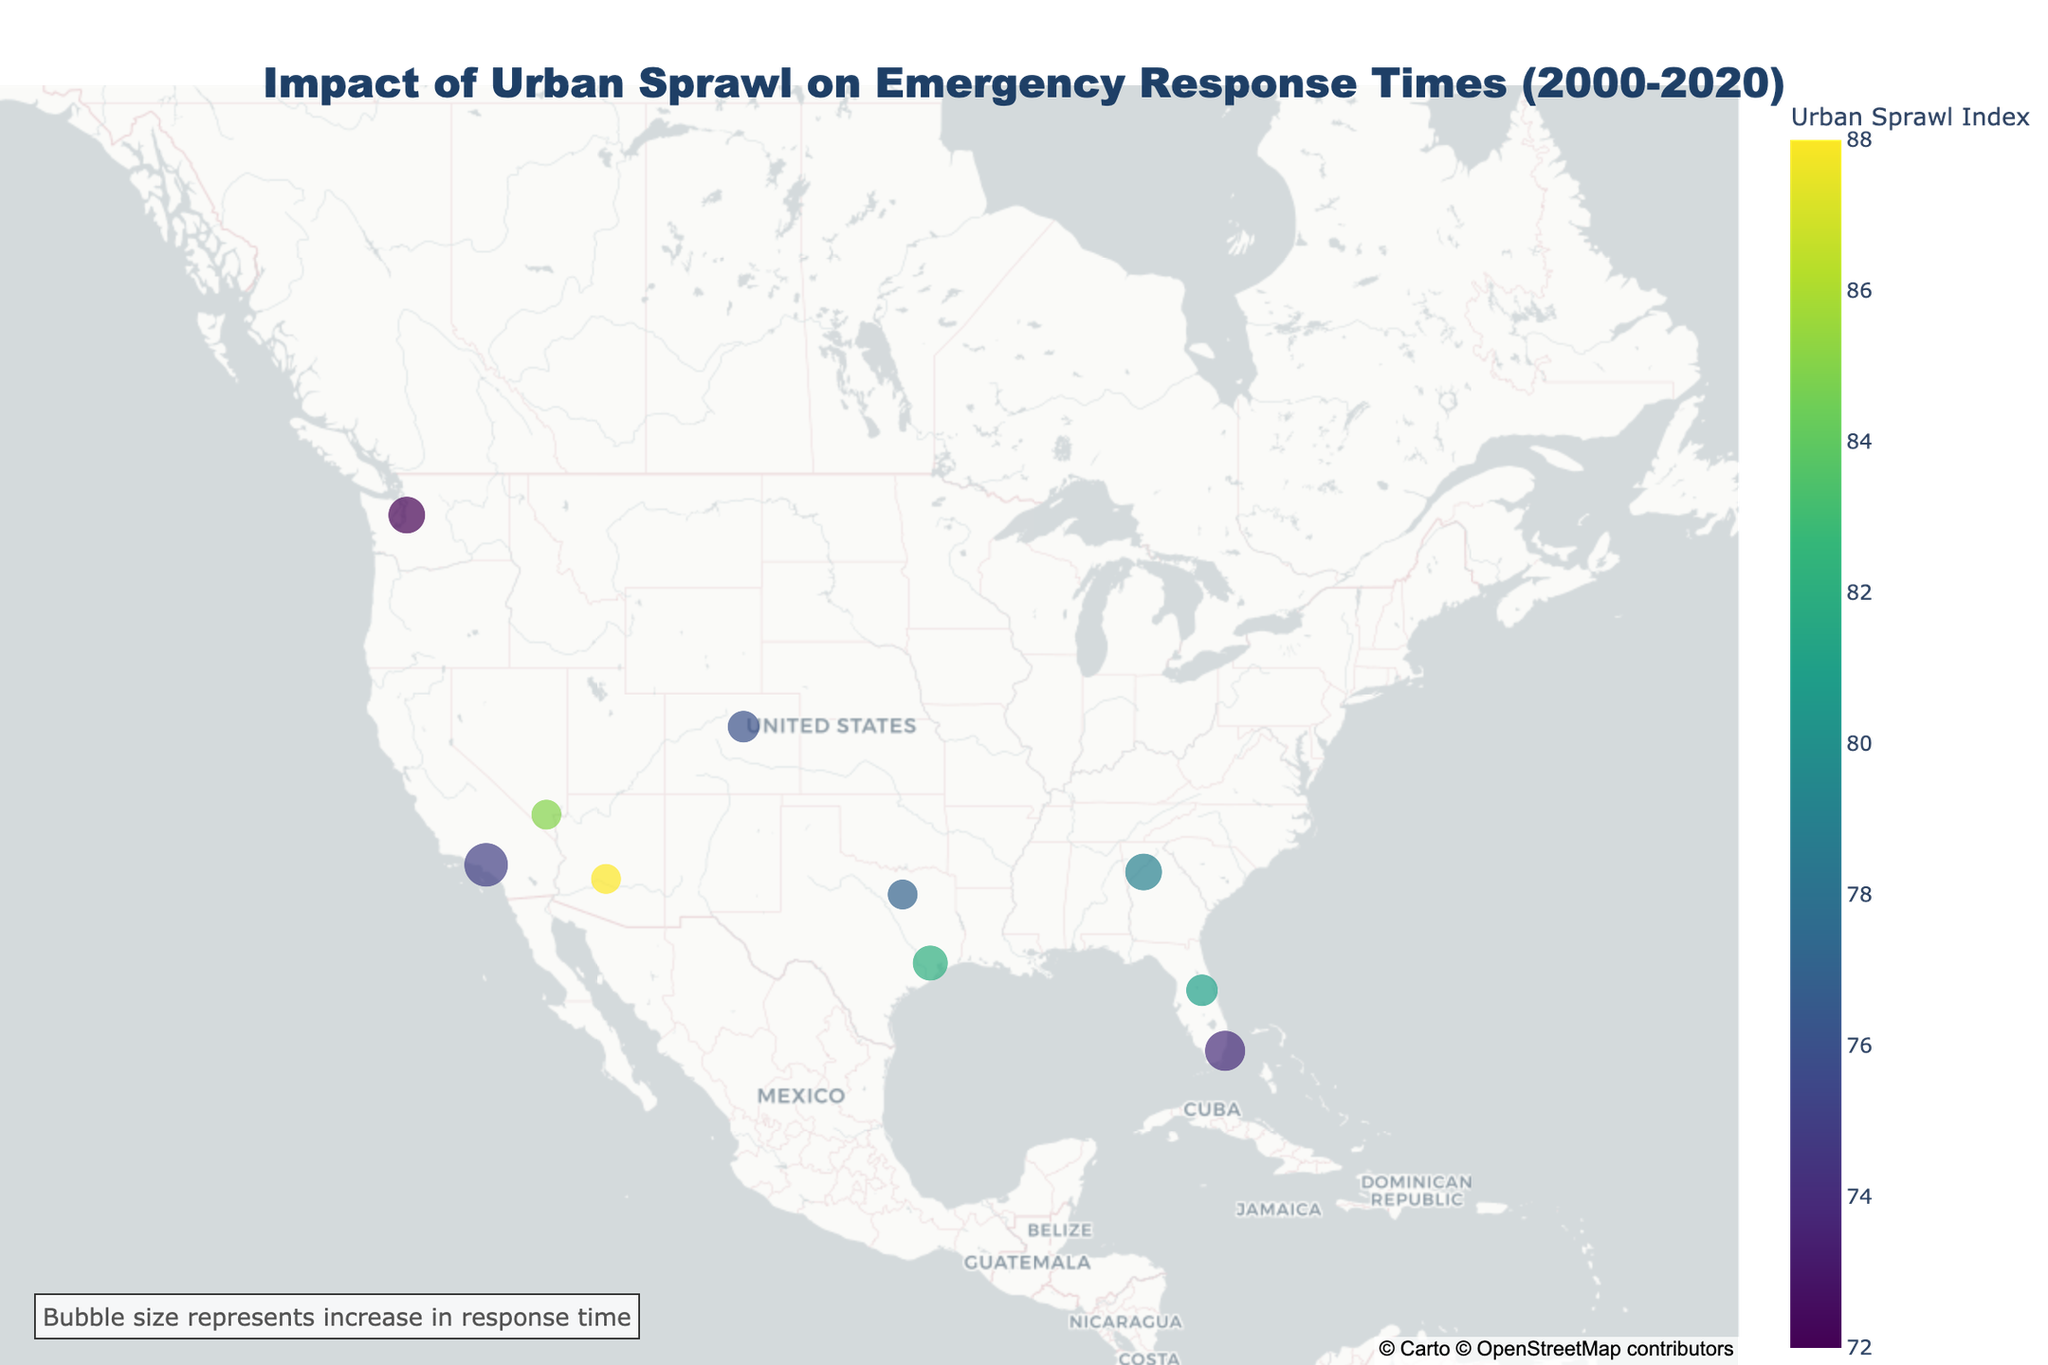How does the title of the plot describe the data presented? The title of the plot states "Impact of Urban Sprawl on Emergency Response Times (2000-2020)," indicating it shows the change in emergency response times and how this is affected by urban sprawl over two decades.
Answer: Impact of Urban Sprawl on Emergency Response Times (2000-2020) Which city has the highest Urban Sprawl Index? By referring to the color scale indicating the Urban Sprawl Index, we see that Phoenix has the highest value of 88.
Answer: Phoenix What information does the bubble size represent? The annotation on the plot mentions that the bubble size represents the increase in response time from 2000 to 2020.
Answer: Increase in response time Which city observed the largest increase in emergency response time? By comparing the sizes of the bubbles, Miami stands out with the largest bubble, showing the greatest increase in emergency response times.
Answer: Miami How is the Population Growth Rate displayed in the plot? The Population Growth Rate is presented in the text box that appears when you hover over a city's marker.
Answer: Hover text How does Seattle’s response time increase compare to Orlando's? Seattle's response time increase, as depicted by its bubble size, is greater than Orlando's, indicating a larger increase in emergency response times in Seattle.
Answer: Greater than Orlando's Of the cities listed, which one had the lowest Urban Sprawl Index? The color scale and the hover text reveal that Seattle has the lowest Urban Sprawl Index of 72.
Answer: Seattle Which city had a higher average response time increase: Dallas or Atlanta? By comparing the sizes of the bubbles for Dallas and Atlanta, Atlanta has a larger bubble, signifying a greater increase in response time compared to Dallas.
Answer: Atlanta What is the relationship between urban sprawl and emergency response times? The plot suggests a positive relationship, as cities with higher Urban Sprawl Indexes tend to have larger increases in emergency response times, indicated by larger bubbles.
Answer: Positive relationship 